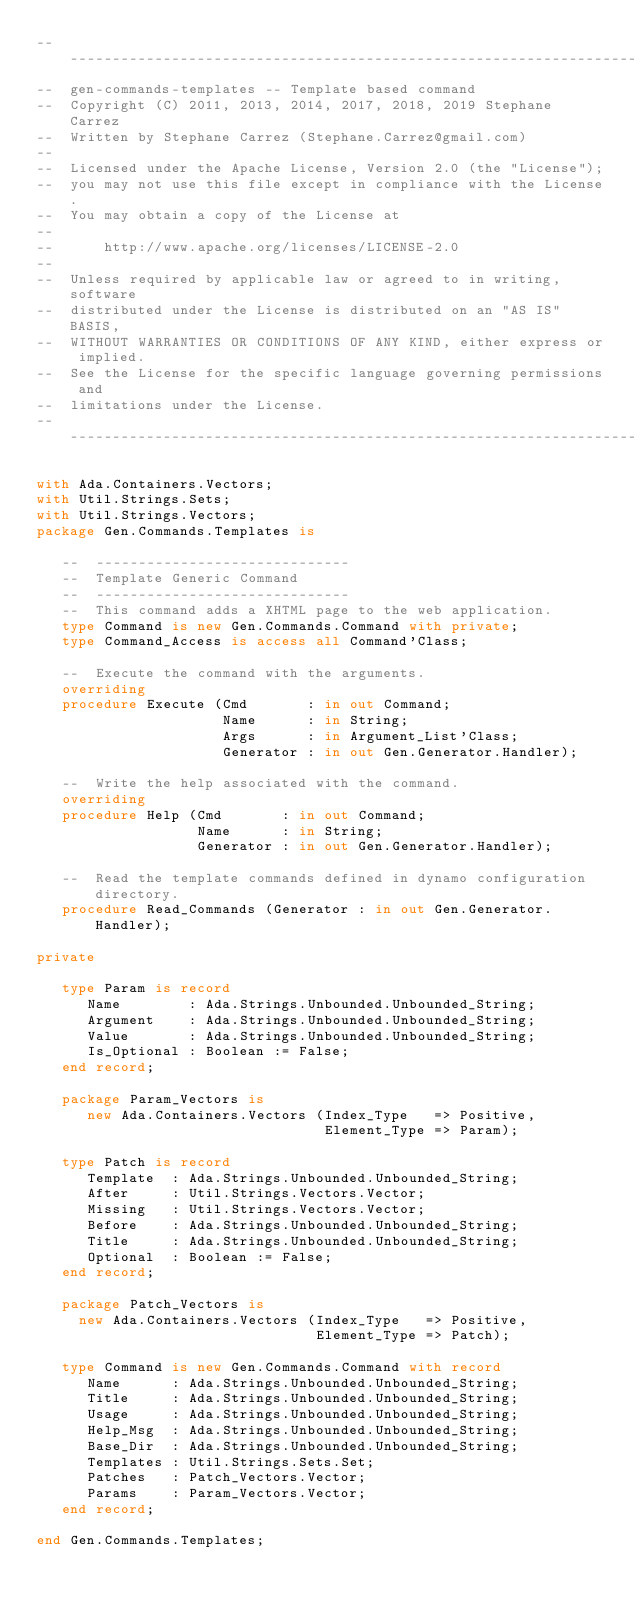<code> <loc_0><loc_0><loc_500><loc_500><_Ada_>-----------------------------------------------------------------------
--  gen-commands-templates -- Template based command
--  Copyright (C) 2011, 2013, 2014, 2017, 2018, 2019 Stephane Carrez
--  Written by Stephane Carrez (Stephane.Carrez@gmail.com)
--
--  Licensed under the Apache License, Version 2.0 (the "License");
--  you may not use this file except in compliance with the License.
--  You may obtain a copy of the License at
--
--      http://www.apache.org/licenses/LICENSE-2.0
--
--  Unless required by applicable law or agreed to in writing, software
--  distributed under the License is distributed on an "AS IS" BASIS,
--  WITHOUT WARRANTIES OR CONDITIONS OF ANY KIND, either express or implied.
--  See the License for the specific language governing permissions and
--  limitations under the License.
-----------------------------------------------------------------------

with Ada.Containers.Vectors;
with Util.Strings.Sets;
with Util.Strings.Vectors;
package Gen.Commands.Templates is

   --  ------------------------------
   --  Template Generic Command
   --  ------------------------------
   --  This command adds a XHTML page to the web application.
   type Command is new Gen.Commands.Command with private;
   type Command_Access is access all Command'Class;

   --  Execute the command with the arguments.
   overriding
   procedure Execute (Cmd       : in out Command;
                      Name      : in String;
                      Args      : in Argument_List'Class;
                      Generator : in out Gen.Generator.Handler);

   --  Write the help associated with the command.
   overriding
   procedure Help (Cmd       : in out Command;
                   Name      : in String;
                   Generator : in out Gen.Generator.Handler);

   --  Read the template commands defined in dynamo configuration directory.
   procedure Read_Commands (Generator : in out Gen.Generator.Handler);

private

   type Param is record
      Name        : Ada.Strings.Unbounded.Unbounded_String;
      Argument    : Ada.Strings.Unbounded.Unbounded_String;
      Value       : Ada.Strings.Unbounded.Unbounded_String;
      Is_Optional : Boolean := False;
   end record;

   package Param_Vectors is
      new Ada.Containers.Vectors (Index_Type   => Positive,
                                  Element_Type => Param);

   type Patch is record
      Template  : Ada.Strings.Unbounded.Unbounded_String;
      After     : Util.Strings.Vectors.Vector;
      Missing   : Util.Strings.Vectors.Vector;
      Before    : Ada.Strings.Unbounded.Unbounded_String;
      Title     : Ada.Strings.Unbounded.Unbounded_String;
      Optional  : Boolean := False;
   end record;

   package Patch_Vectors is
     new Ada.Containers.Vectors (Index_Type   => Positive,
                                 Element_Type => Patch);

   type Command is new Gen.Commands.Command with record
      Name      : Ada.Strings.Unbounded.Unbounded_String;
      Title     : Ada.Strings.Unbounded.Unbounded_String;
      Usage     : Ada.Strings.Unbounded.Unbounded_String;
      Help_Msg  : Ada.Strings.Unbounded.Unbounded_String;
      Base_Dir  : Ada.Strings.Unbounded.Unbounded_String;
      Templates : Util.Strings.Sets.Set;
      Patches   : Patch_Vectors.Vector;
      Params    : Param_Vectors.Vector;
   end record;

end Gen.Commands.Templates;
</code> 